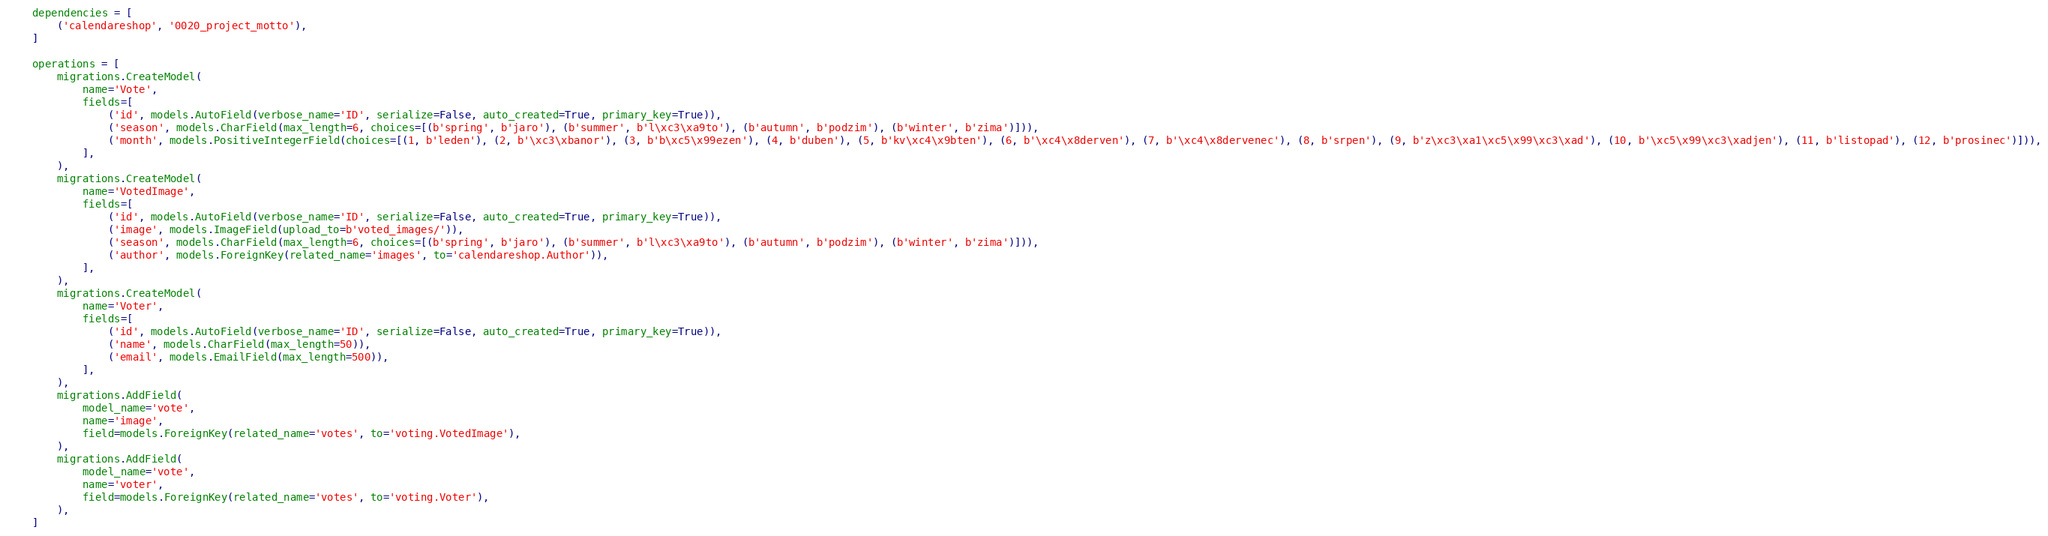Convert code to text. <code><loc_0><loc_0><loc_500><loc_500><_Python_>
    dependencies = [
        ('calendareshop', '0020_project_motto'),
    ]

    operations = [
        migrations.CreateModel(
            name='Vote',
            fields=[
                ('id', models.AutoField(verbose_name='ID', serialize=False, auto_created=True, primary_key=True)),
                ('season', models.CharField(max_length=6, choices=[(b'spring', b'jaro'), (b'summer', b'l\xc3\xa9to'), (b'autumn', b'podzim'), (b'winter', b'zima')])),
                ('month', models.PositiveIntegerField(choices=[(1, b'leden'), (2, b'\xc3\xbanor'), (3, b'b\xc5\x99ezen'), (4, b'duben'), (5, b'kv\xc4\x9bten'), (6, b'\xc4\x8derven'), (7, b'\xc4\x8dervenec'), (8, b'srpen'), (9, b'z\xc3\xa1\xc5\x99\xc3\xad'), (10, b'\xc5\x99\xc3\xadjen'), (11, b'listopad'), (12, b'prosinec')])),
            ],
        ),
        migrations.CreateModel(
            name='VotedImage',
            fields=[
                ('id', models.AutoField(verbose_name='ID', serialize=False, auto_created=True, primary_key=True)),
                ('image', models.ImageField(upload_to=b'voted_images/')),
                ('season', models.CharField(max_length=6, choices=[(b'spring', b'jaro'), (b'summer', b'l\xc3\xa9to'), (b'autumn', b'podzim'), (b'winter', b'zima')])),
                ('author', models.ForeignKey(related_name='images', to='calendareshop.Author')),
            ],
        ),
        migrations.CreateModel(
            name='Voter',
            fields=[
                ('id', models.AutoField(verbose_name='ID', serialize=False, auto_created=True, primary_key=True)),
                ('name', models.CharField(max_length=50)),
                ('email', models.EmailField(max_length=500)),
            ],
        ),
        migrations.AddField(
            model_name='vote',
            name='image',
            field=models.ForeignKey(related_name='votes', to='voting.VotedImage'),
        ),
        migrations.AddField(
            model_name='vote',
            name='voter',
            field=models.ForeignKey(related_name='votes', to='voting.Voter'),
        ),
    ]
</code> 